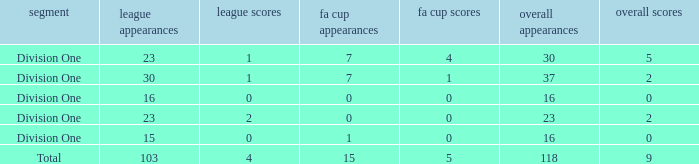It has fa cup goals larger than 0 and total goals of 0, what is the average total apps? None. 